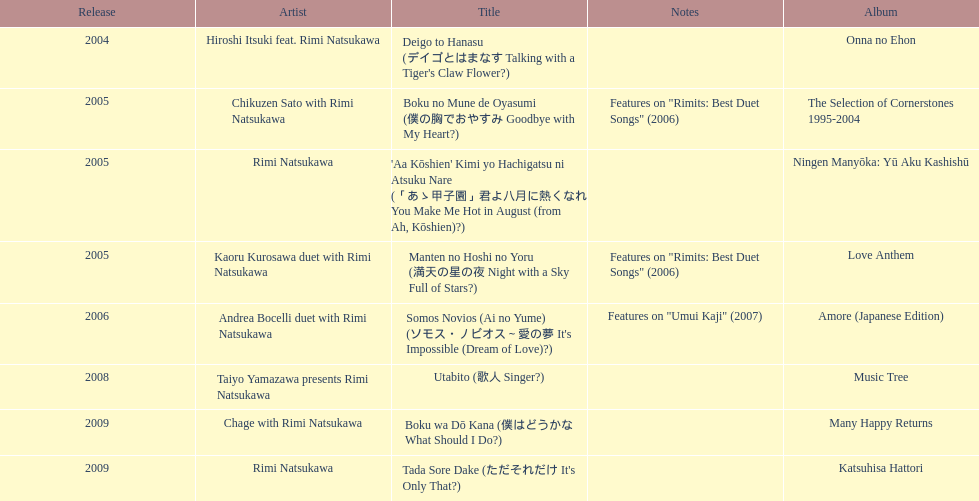In what year was onna no ehon made available? 2004. When was the selection of cornerstones 1995-2004 published? 2005. What was published in 2008? Music Tree. 